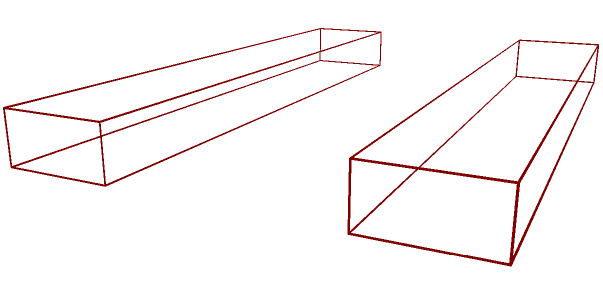A traditional Basque txalaparta consists of two wooden boards supported horizontally. Each board measures 6 cm in length, 1 cm in width, and 0.5 cm in height. If the boards are placed parallel to each other with a 3 cm gap between them, what is the total volume of wood used in making this txalaparta? To find the total volume of wood used in the txalaparta, we need to:

1. Calculate the volume of one board:
   $V_{board} = length \times width \times height$
   $V_{board} = 6 \text{ cm} \times 1 \text{ cm} \times 0.5 \text{ cm} = 3 \text{ cm}^3$

2. Since there are two identical boards, multiply the volume of one board by 2:
   $V_{total} = 2 \times V_{board}$
   $V_{total} = 2 \times 3 \text{ cm}^3 = 6 \text{ cm}^3$

The total volume of wood used in making this txalaparta is 6 cubic centimeters.
Answer: $6 \text{ cm}^3$ 